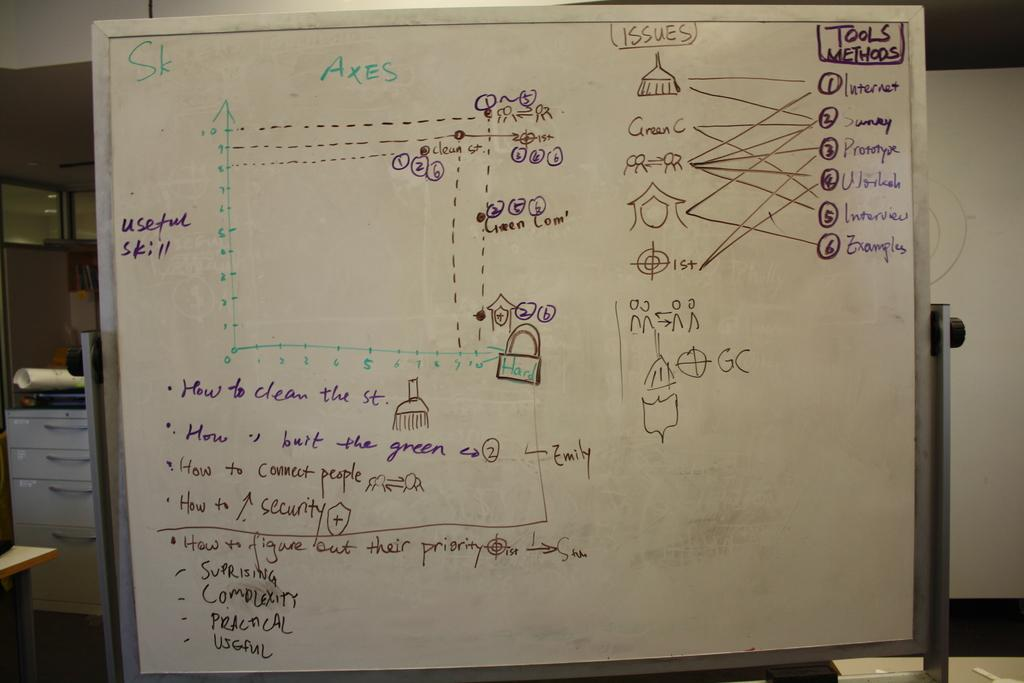<image>
Create a compact narrative representing the image presented. A green label that says AXES is on a white board over an empty graph. 